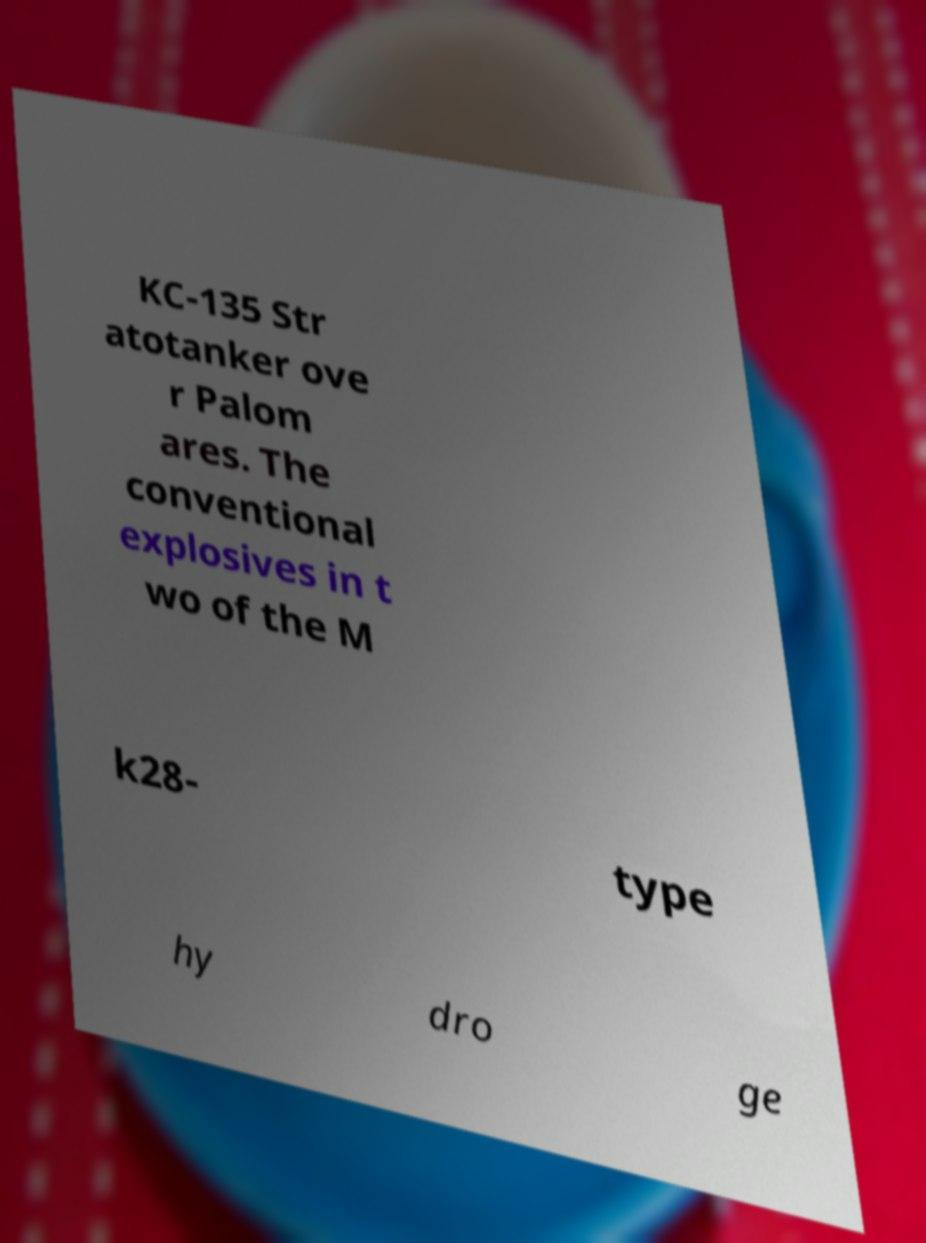Can you read and provide the text displayed in the image?This photo seems to have some interesting text. Can you extract and type it out for me? KC-135 Str atotanker ove r Palom ares. The conventional explosives in t wo of the M k28- type hy dro ge 